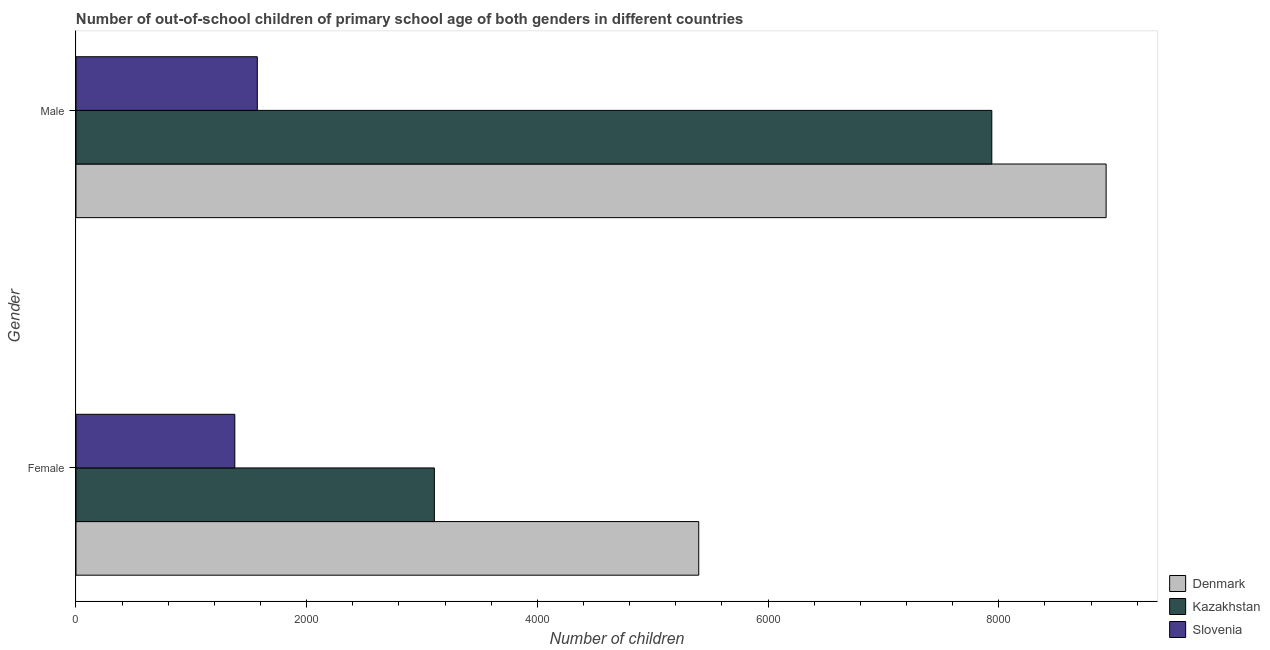Are the number of bars on each tick of the Y-axis equal?
Your answer should be very brief. Yes. How many bars are there on the 2nd tick from the bottom?
Offer a very short reply. 3. What is the label of the 2nd group of bars from the top?
Your answer should be compact. Female. What is the number of male out-of-school students in Slovenia?
Ensure brevity in your answer.  1572. Across all countries, what is the maximum number of female out-of-school students?
Your answer should be compact. 5399. Across all countries, what is the minimum number of male out-of-school students?
Offer a very short reply. 1572. In which country was the number of female out-of-school students minimum?
Ensure brevity in your answer.  Slovenia. What is the total number of male out-of-school students in the graph?
Offer a terse response. 1.84e+04. What is the difference between the number of male out-of-school students in Kazakhstan and that in Slovenia?
Your response must be concise. 6368. What is the difference between the number of male out-of-school students in Kazakhstan and the number of female out-of-school students in Denmark?
Your response must be concise. 2541. What is the average number of female out-of-school students per country?
Keep it short and to the point. 3294.33. What is the difference between the number of male out-of-school students and number of female out-of-school students in Denmark?
Provide a succinct answer. 3532. In how many countries, is the number of male out-of-school students greater than 2000 ?
Your response must be concise. 2. What is the ratio of the number of male out-of-school students in Slovenia to that in Kazakhstan?
Ensure brevity in your answer.  0.2. In how many countries, is the number of female out-of-school students greater than the average number of female out-of-school students taken over all countries?
Provide a succinct answer. 1. What does the 3rd bar from the top in Male represents?
Your response must be concise. Denmark. What does the 3rd bar from the bottom in Female represents?
Your answer should be very brief. Slovenia. How many bars are there?
Your response must be concise. 6. Are all the bars in the graph horizontal?
Offer a very short reply. Yes. How many countries are there in the graph?
Provide a short and direct response. 3. Are the values on the major ticks of X-axis written in scientific E-notation?
Your answer should be compact. No. Does the graph contain any zero values?
Provide a short and direct response. No. Where does the legend appear in the graph?
Your answer should be very brief. Bottom right. How are the legend labels stacked?
Ensure brevity in your answer.  Vertical. What is the title of the graph?
Keep it short and to the point. Number of out-of-school children of primary school age of both genders in different countries. What is the label or title of the X-axis?
Your answer should be compact. Number of children. What is the label or title of the Y-axis?
Offer a terse response. Gender. What is the Number of children of Denmark in Female?
Your answer should be very brief. 5399. What is the Number of children of Kazakhstan in Female?
Give a very brief answer. 3107. What is the Number of children of Slovenia in Female?
Your answer should be very brief. 1377. What is the Number of children in Denmark in Male?
Make the answer very short. 8931. What is the Number of children in Kazakhstan in Male?
Offer a terse response. 7940. What is the Number of children of Slovenia in Male?
Provide a short and direct response. 1572. Across all Gender, what is the maximum Number of children in Denmark?
Make the answer very short. 8931. Across all Gender, what is the maximum Number of children in Kazakhstan?
Provide a succinct answer. 7940. Across all Gender, what is the maximum Number of children in Slovenia?
Offer a terse response. 1572. Across all Gender, what is the minimum Number of children of Denmark?
Provide a short and direct response. 5399. Across all Gender, what is the minimum Number of children of Kazakhstan?
Offer a very short reply. 3107. Across all Gender, what is the minimum Number of children in Slovenia?
Ensure brevity in your answer.  1377. What is the total Number of children of Denmark in the graph?
Offer a terse response. 1.43e+04. What is the total Number of children in Kazakhstan in the graph?
Give a very brief answer. 1.10e+04. What is the total Number of children of Slovenia in the graph?
Keep it short and to the point. 2949. What is the difference between the Number of children in Denmark in Female and that in Male?
Ensure brevity in your answer.  -3532. What is the difference between the Number of children of Kazakhstan in Female and that in Male?
Provide a succinct answer. -4833. What is the difference between the Number of children of Slovenia in Female and that in Male?
Ensure brevity in your answer.  -195. What is the difference between the Number of children of Denmark in Female and the Number of children of Kazakhstan in Male?
Your answer should be compact. -2541. What is the difference between the Number of children in Denmark in Female and the Number of children in Slovenia in Male?
Provide a short and direct response. 3827. What is the difference between the Number of children of Kazakhstan in Female and the Number of children of Slovenia in Male?
Provide a succinct answer. 1535. What is the average Number of children of Denmark per Gender?
Provide a succinct answer. 7165. What is the average Number of children of Kazakhstan per Gender?
Your response must be concise. 5523.5. What is the average Number of children in Slovenia per Gender?
Make the answer very short. 1474.5. What is the difference between the Number of children in Denmark and Number of children in Kazakhstan in Female?
Your answer should be very brief. 2292. What is the difference between the Number of children of Denmark and Number of children of Slovenia in Female?
Make the answer very short. 4022. What is the difference between the Number of children of Kazakhstan and Number of children of Slovenia in Female?
Ensure brevity in your answer.  1730. What is the difference between the Number of children of Denmark and Number of children of Kazakhstan in Male?
Make the answer very short. 991. What is the difference between the Number of children of Denmark and Number of children of Slovenia in Male?
Keep it short and to the point. 7359. What is the difference between the Number of children in Kazakhstan and Number of children in Slovenia in Male?
Ensure brevity in your answer.  6368. What is the ratio of the Number of children of Denmark in Female to that in Male?
Provide a short and direct response. 0.6. What is the ratio of the Number of children of Kazakhstan in Female to that in Male?
Keep it short and to the point. 0.39. What is the ratio of the Number of children of Slovenia in Female to that in Male?
Provide a succinct answer. 0.88. What is the difference between the highest and the second highest Number of children in Denmark?
Your answer should be very brief. 3532. What is the difference between the highest and the second highest Number of children in Kazakhstan?
Make the answer very short. 4833. What is the difference between the highest and the second highest Number of children of Slovenia?
Provide a short and direct response. 195. What is the difference between the highest and the lowest Number of children in Denmark?
Offer a terse response. 3532. What is the difference between the highest and the lowest Number of children in Kazakhstan?
Your response must be concise. 4833. What is the difference between the highest and the lowest Number of children of Slovenia?
Your answer should be compact. 195. 